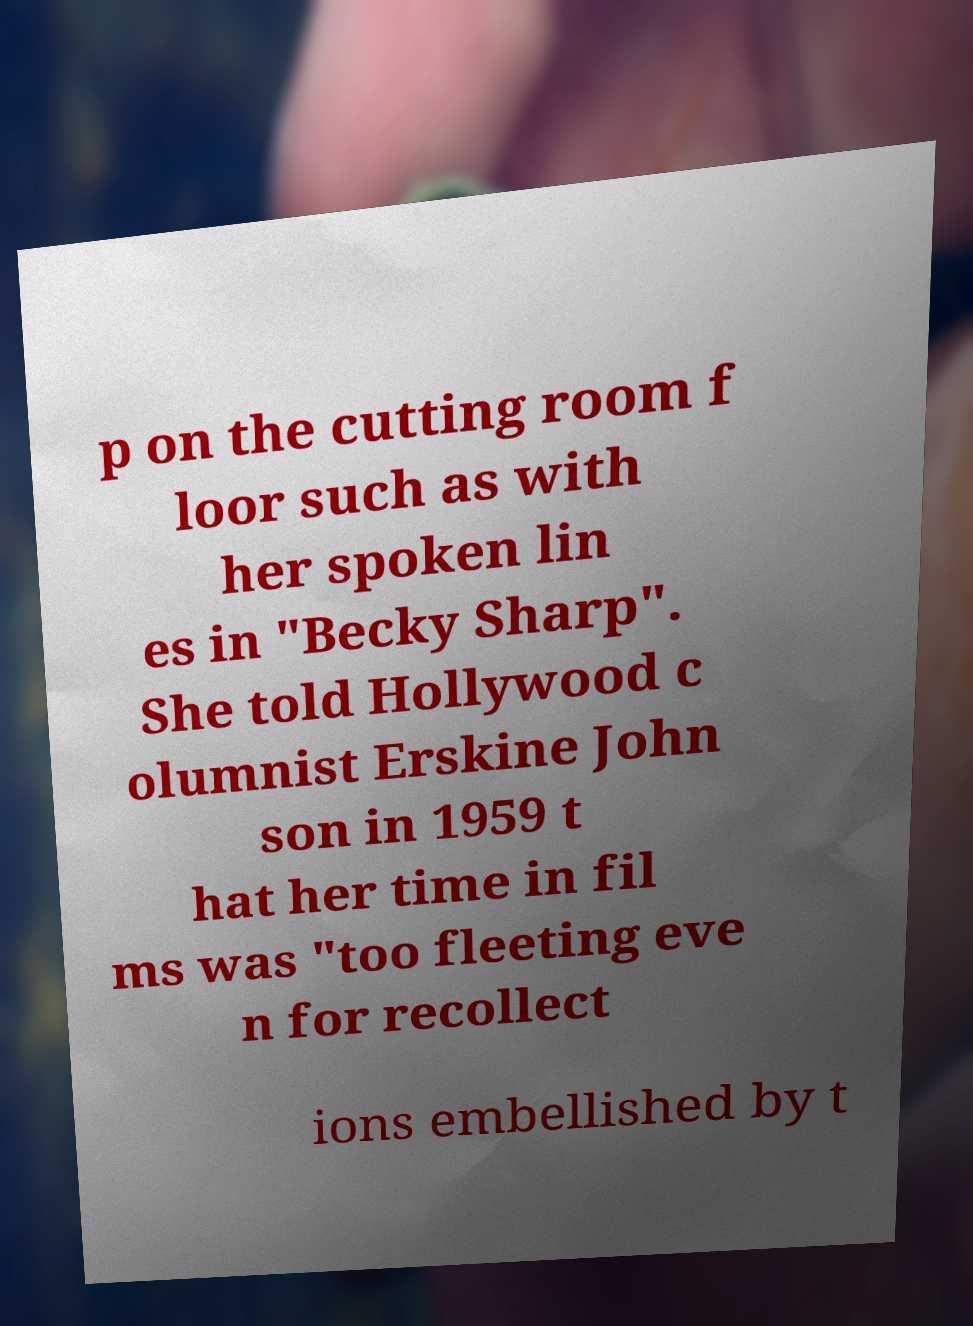Can you read and provide the text displayed in the image?This photo seems to have some interesting text. Can you extract and type it out for me? p on the cutting room f loor such as with her spoken lin es in "Becky Sharp". She told Hollywood c olumnist Erskine John son in 1959 t hat her time in fil ms was "too fleeting eve n for recollect ions embellished by t 